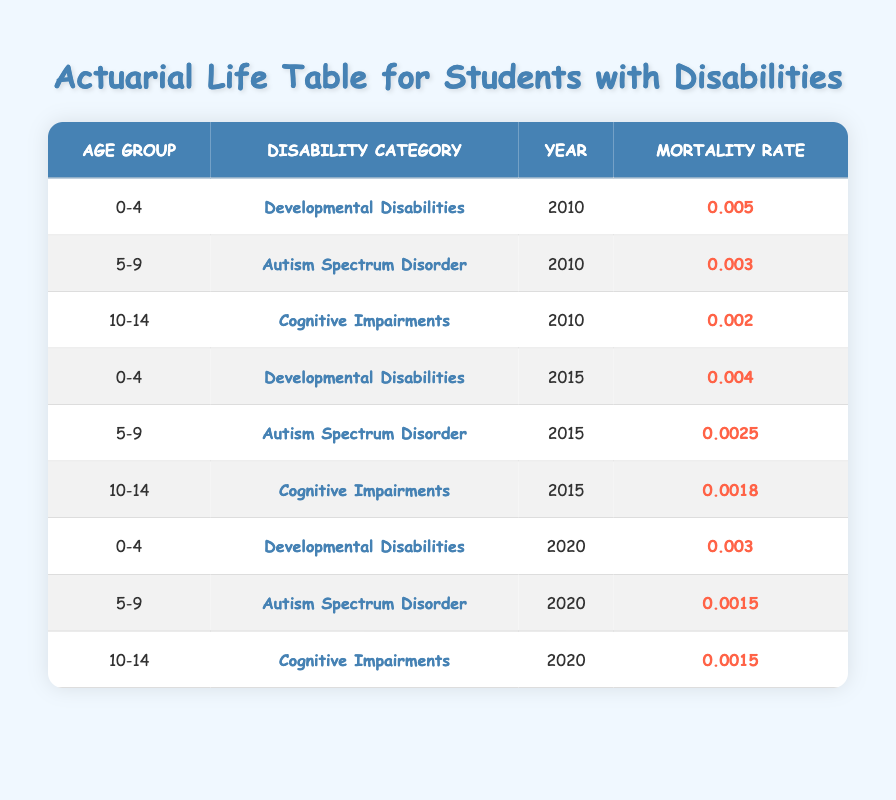What is the mortality rate for students with developmental disabilities aged 0-4 in 2010? The table shows the mortality rate specifically for the age group 0-4 under the category of Developmental Disabilities for the year 2010 is 0.005.
Answer: 0.005 What was the mortality rate for students with autism spectrum disorder aged 5-9 in 2020? Looking at the row for the age group 5-9 and the category of Autism Spectrum Disorder for the year 2020, the mortality rate is 0.0015.
Answer: 0.0015 Which age group had the highest mortality rate for cognitive impairments in 2015? For cognitive impairments in 2015, the mortality rates for age groups are: 10-14 (0.0018), 0-4 (not present), and 5-9 (not present), therefore the highest mortality rate is 0.0018 for the age group 10-14.
Answer: 10-14 Is the mortality rate for developmental disabilities lower in 2015 compared to 2010? The mortality rate for developmental disabilities in 2010 is 0.005 and in 2015 is 0.004. Since 0.004 is lower than 0.005, the rate indeed decreased.
Answer: Yes What is the average mortality rate for students aged 0-4 across all years? Summing the mortality rates for the age group 0-4: 0.005 (2010) + 0.004 (2015) + 0.003 (2020) = 0.012 and then dividing by 3 (the number of years) gives 0.012 / 3 = 0.004.
Answer: 0.004 Which disability category showed the greatest decrease in mortality rate from 2010 to 2020? The mortality rates for students aged 5-9 with autism spectrum disorder were 0.003 in 2010 and decreased to 0.0015 in 2020. For cognitive impairments, it decreased from 0.002 in 2010 to 0.0015 in 2020. Developmental disabilities decreased from 0.005 in 2010 to 0.003 in 2020. The greatest decrease is seen in autism spectrum disorder from 0.003 to 0.0015, a change of 0.0015.
Answer: Autism Spectrum Disorder Are there any mortality rates recorded for students aged 15 and above? Reviewing the table, there are no entries showing any mortality rates for students aged 15 and above in any of the years.
Answer: No 